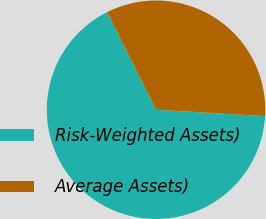Convert chart. <chart><loc_0><loc_0><loc_500><loc_500><pie_chart><fcel>Risk-Weighted Assets)<fcel>Average Assets)<nl><fcel>66.67%<fcel>33.33%<nl></chart> 